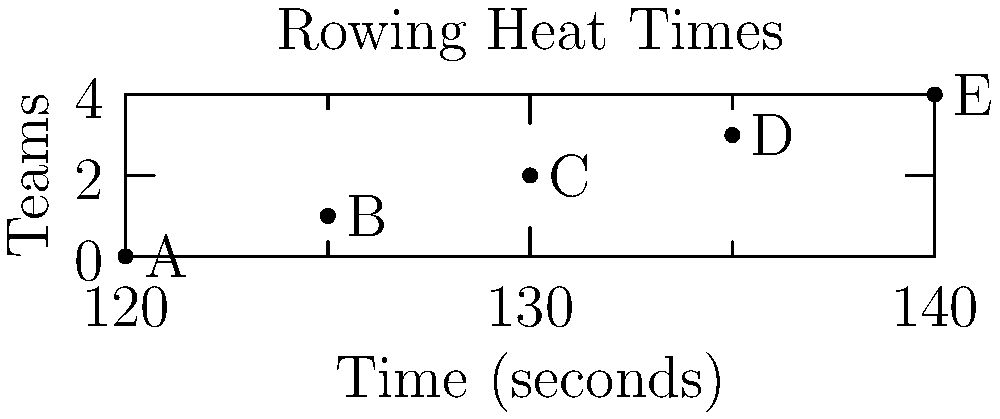In a rowing competition, five teams (A, B, C, D, E) need to be divided into two heats. The organizers want to ensure that the two fastest teams are in different heats. Given the finishing times (in seconds) shown in the graph, how many ways are there to divide the teams into two heats of 2 and 3 teams, respectively, while satisfying this condition? Let's approach this step-by-step:

1. First, identify the two fastest teams:
   Team A: 120 seconds
   Team B: 125 seconds

2. These two teams must be in different heats.

3. Now, we need to distribute the remaining three teams (C, D, E) between the two heats.

4. There are two possible scenarios:
   a) A in the 2-team heat, B in the 3-team heat
   b) B in the 2-team heat, A in the 3-team heat

5. For scenario a):
   - We need to choose 1 team out of C, D, E to join A in the 2-team heat.
   - This can be done in $\binom{3}{1} = 3$ ways.

6. For scenario b):
   - We need to choose 2 teams out of C, D, E to join A in the 3-team heat.
   - This can also be done in $\binom{3}{2} = 3$ ways.

7. By the addition principle, the total number of ways is:
   $3 + 3 = 6$

Therefore, there are 6 ways to divide the teams into two heats while ensuring the two fastest teams are in different heats.
Answer: 6 ways 